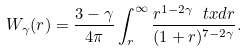Convert formula to latex. <formula><loc_0><loc_0><loc_500><loc_500>W _ { \gamma } ( r ) = \frac { 3 - \gamma } { 4 \pi } \int _ { r } ^ { \infty } \frac { r ^ { 1 - 2 \gamma } \ t x d r } { ( 1 + r ) ^ { 7 - 2 \gamma } } .</formula> 